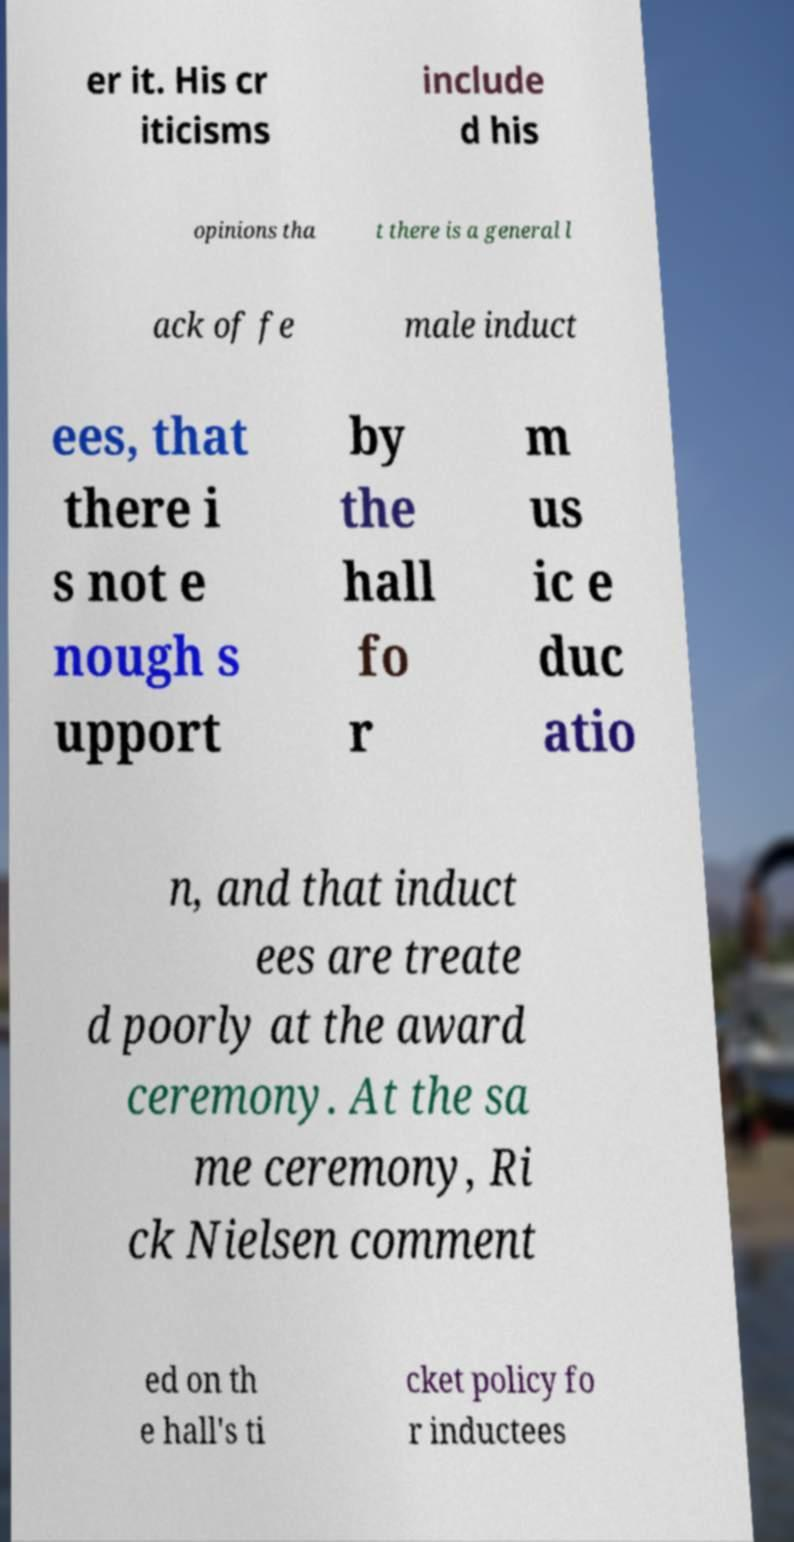What messages or text are displayed in this image? I need them in a readable, typed format. er it. His cr iticisms include d his opinions tha t there is a general l ack of fe male induct ees, that there i s not e nough s upport by the hall fo r m us ic e duc atio n, and that induct ees are treate d poorly at the award ceremony. At the sa me ceremony, Ri ck Nielsen comment ed on th e hall's ti cket policy fo r inductees 